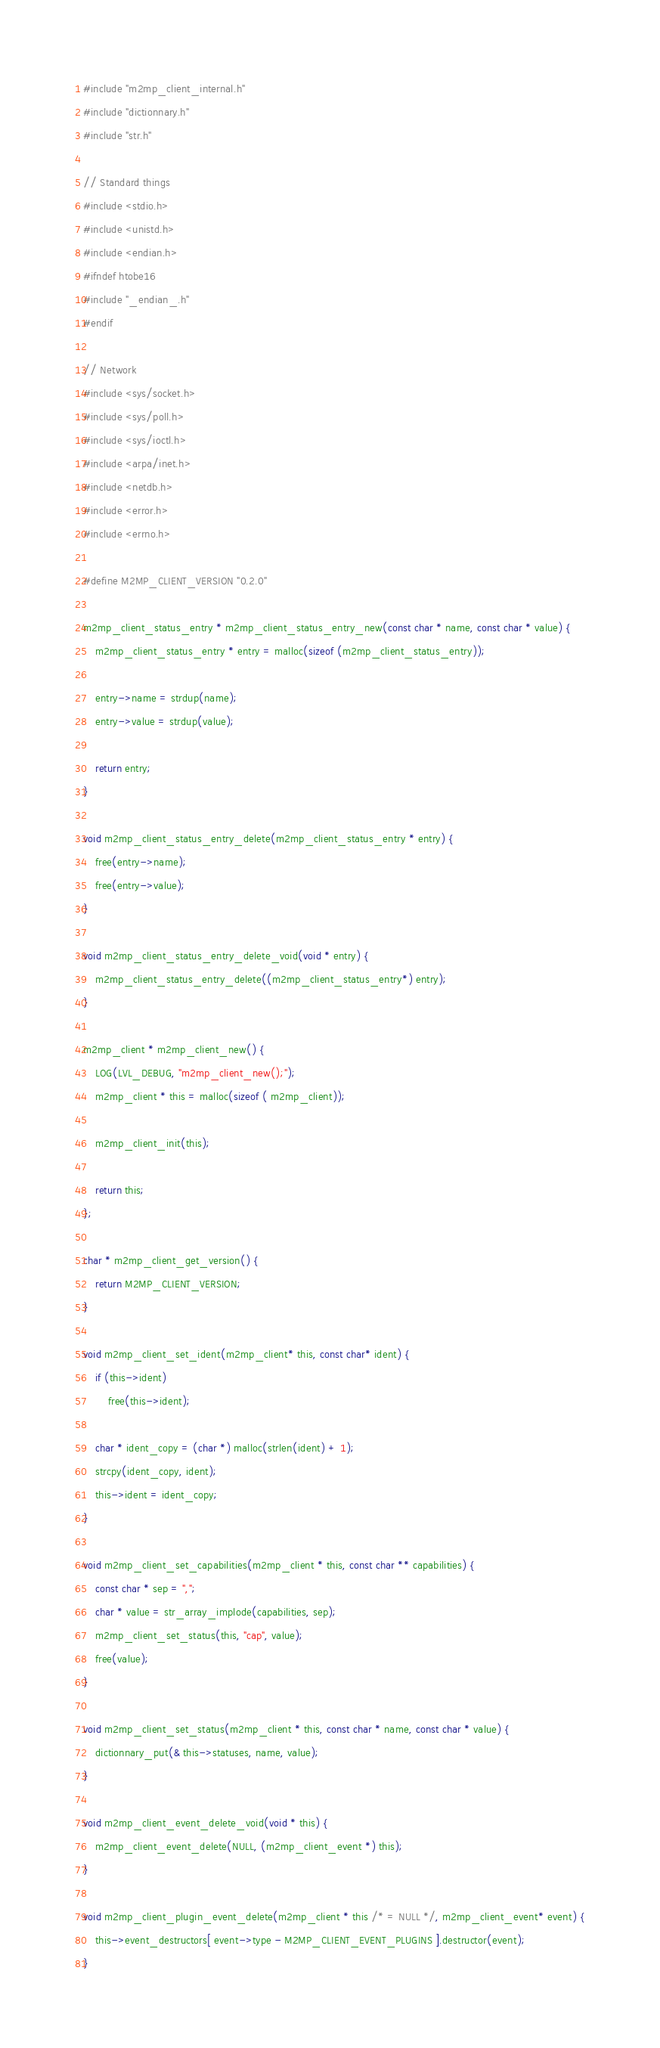<code> <loc_0><loc_0><loc_500><loc_500><_C_>#include "m2mp_client_internal.h"
#include "dictionnary.h"
#include "str.h"

// Standard things
#include <stdio.h>
#include <unistd.h>
#include <endian.h>
#ifndef htobe16
#include "_endian_.h"
#endif

// Network
#include <sys/socket.h>
#include <sys/poll.h>
#include <sys/ioctl.h>
#include <arpa/inet.h>
#include <netdb.h>
#include <error.h>
#include <errno.h>

#define M2MP_CLIENT_VERSION "0.2.0"

m2mp_client_status_entry * m2mp_client_status_entry_new(const char * name, const char * value) {
	m2mp_client_status_entry * entry = malloc(sizeof (m2mp_client_status_entry));

	entry->name = strdup(name);
	entry->value = strdup(value);

	return entry;
}

void m2mp_client_status_entry_delete(m2mp_client_status_entry * entry) {
	free(entry->name);
	free(entry->value);
}

void m2mp_client_status_entry_delete_void(void * entry) {
	m2mp_client_status_entry_delete((m2mp_client_status_entry*) entry);
}

m2mp_client * m2mp_client_new() {
	LOG(LVL_DEBUG, "m2mp_client_new();");
	m2mp_client * this = malloc(sizeof ( m2mp_client));

	m2mp_client_init(this);

	return this;
};

char * m2mp_client_get_version() {
	return M2MP_CLIENT_VERSION;
}

void m2mp_client_set_ident(m2mp_client* this, const char* ident) {
	if (this->ident)
		free(this->ident);

	char * ident_copy = (char *) malloc(strlen(ident) + 1);
	strcpy(ident_copy, ident);
	this->ident = ident_copy;
}

void m2mp_client_set_capabilities(m2mp_client * this, const char ** capabilities) {
	const char * sep = ",";
	char * value = str_array_implode(capabilities, sep);
	m2mp_client_set_status(this, "cap", value);
	free(value);
}

void m2mp_client_set_status(m2mp_client * this, const char * name, const char * value) {
	dictionnary_put(& this->statuses, name, value);
}

void m2mp_client_event_delete_void(void * this) {
	m2mp_client_event_delete(NULL, (m2mp_client_event *) this);
}

void m2mp_client_plugin_event_delete(m2mp_client * this /* = NULL */, m2mp_client_event* event) {
	this->event_destructors[ event->type - M2MP_CLIENT_EVENT_PLUGINS ].destructor(event);
}
</code> 